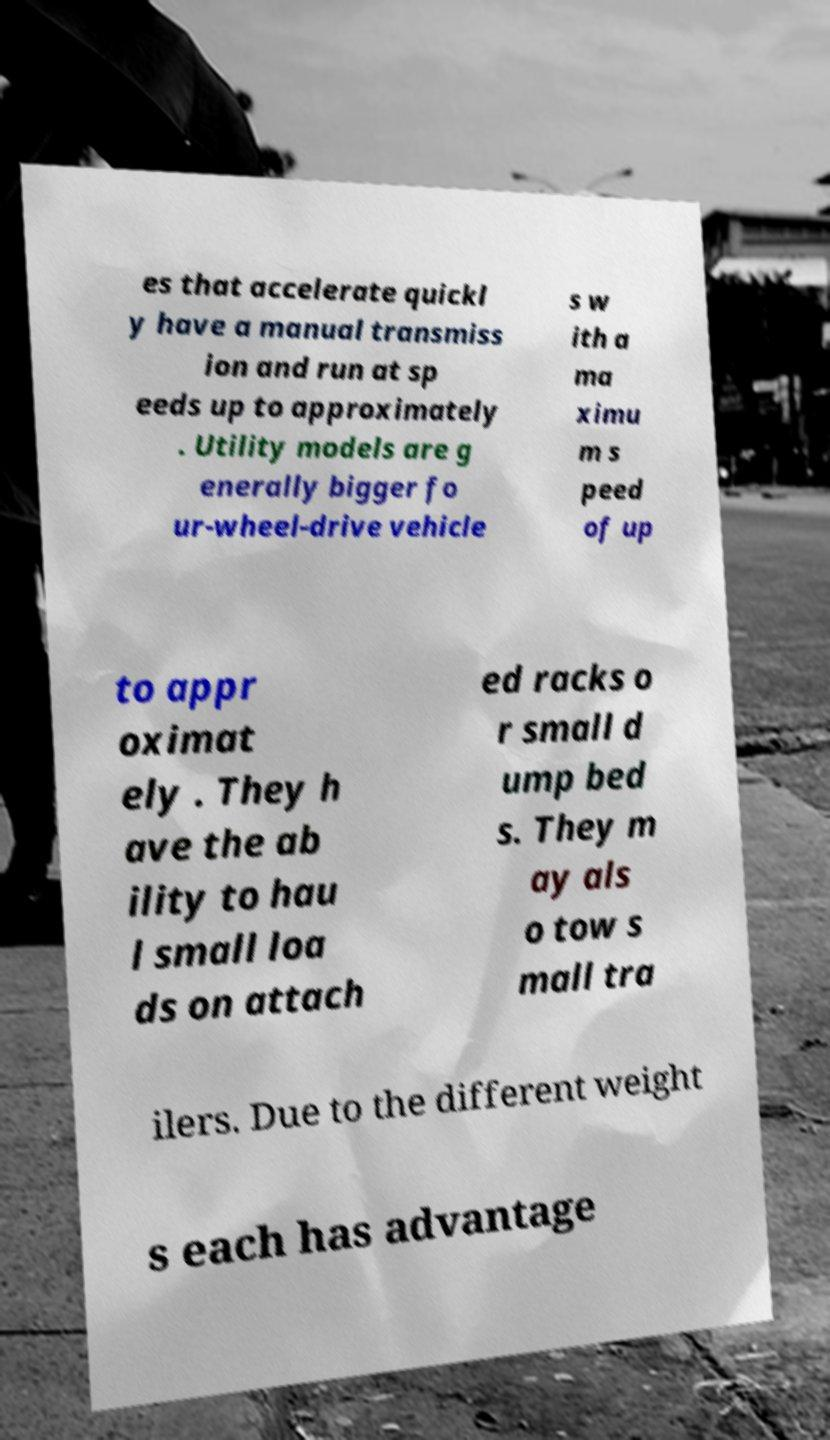Could you assist in decoding the text presented in this image and type it out clearly? es that accelerate quickl y have a manual transmiss ion and run at sp eeds up to approximately . Utility models are g enerally bigger fo ur-wheel-drive vehicle s w ith a ma ximu m s peed of up to appr oximat ely . They h ave the ab ility to hau l small loa ds on attach ed racks o r small d ump bed s. They m ay als o tow s mall tra ilers. Due to the different weight s each has advantage 